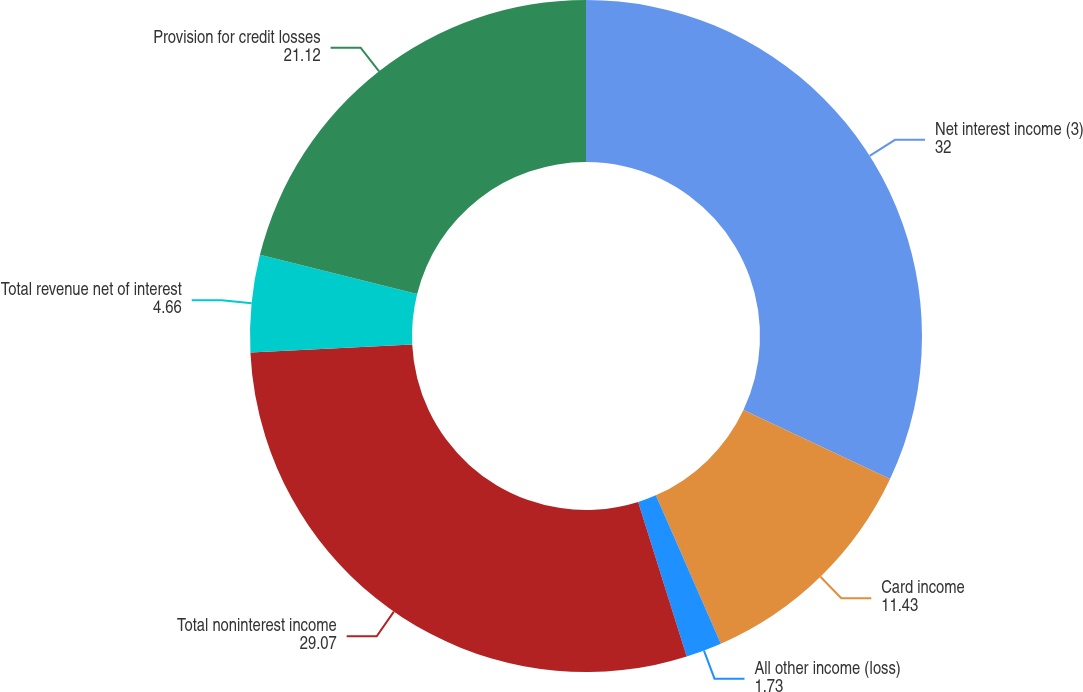<chart> <loc_0><loc_0><loc_500><loc_500><pie_chart><fcel>Net interest income (3)<fcel>Card income<fcel>All other income (loss)<fcel>Total noninterest income<fcel>Total revenue net of interest<fcel>Provision for credit losses<nl><fcel>32.0%<fcel>11.43%<fcel>1.73%<fcel>29.07%<fcel>4.66%<fcel>21.12%<nl></chart> 